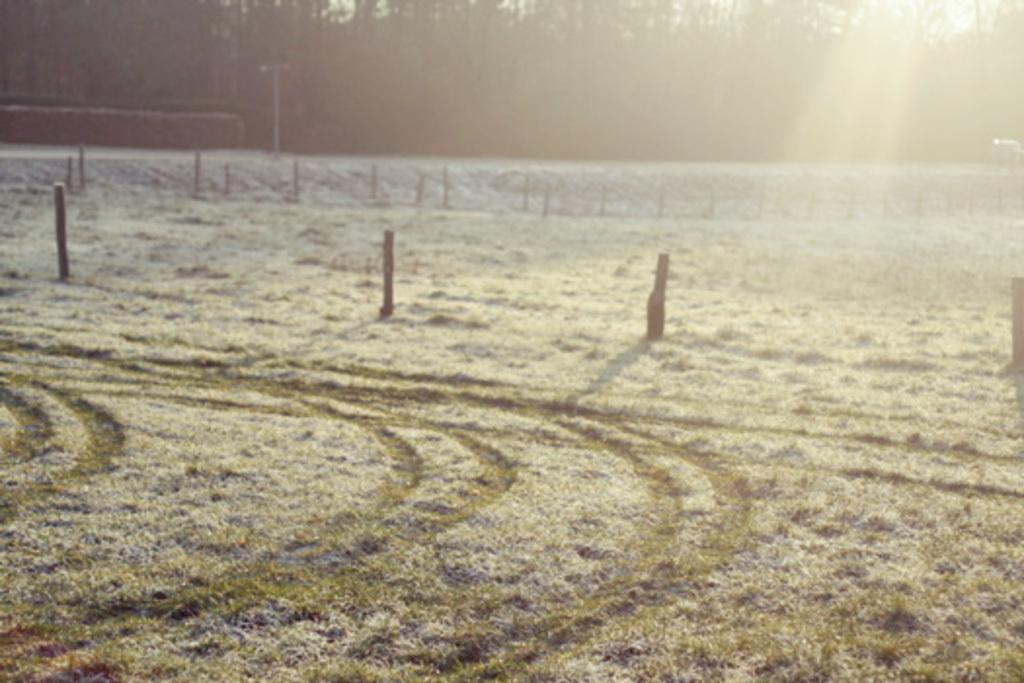What type of natural materials can be seen in the front of the image? There are wooden logs and dried grass in the front of the image. What is located in the background of the image? There is a pole and trees in the background of the image. How many chickens are sitting on the wooden logs in the image? There are no chickens present in the image; it features wooden logs and dried grass in the front. What type of dinosaurs can be seen walking through the dried grass in the image? There are no dinosaurs present in the image; it features wooden logs and dried grass in the front. 